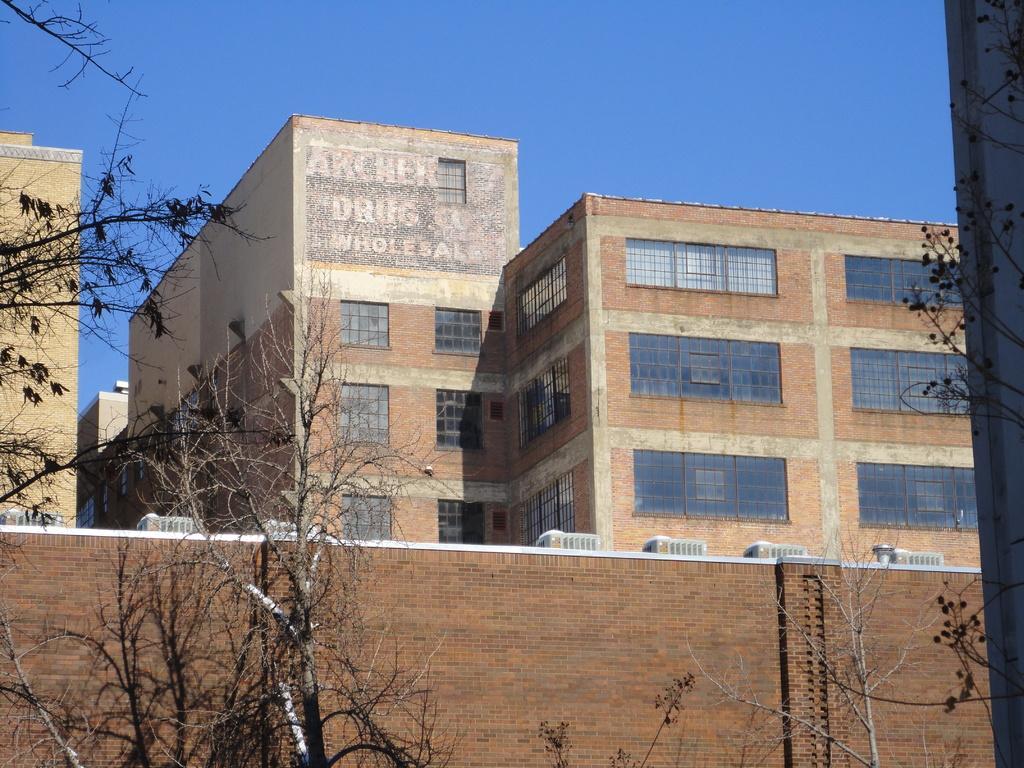How would you summarize this image in a sentence or two? In this image I can see few trees and the brown colored wall. In the background I can see few buildings which are brown and cream in color and the sky. 